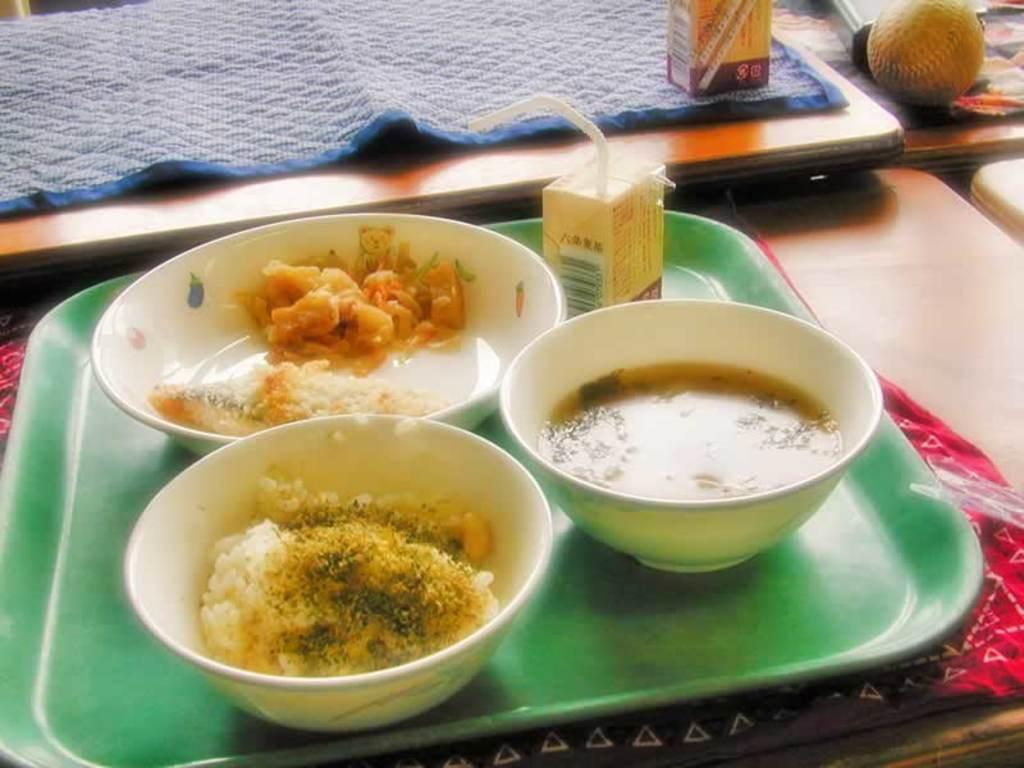What is in the bowl that is visible in the image? There are food items in a bowl in the image. Where is the bowl located? The bowl is on a tray in the image. What else can be seen on the tray or table? There are other objects arranged on a table in the image. What type of jewel is prominently displayed on the table in the image? There is no jewel present in the image; it features food items in a bowl on a tray and other objects arranged on a table. 